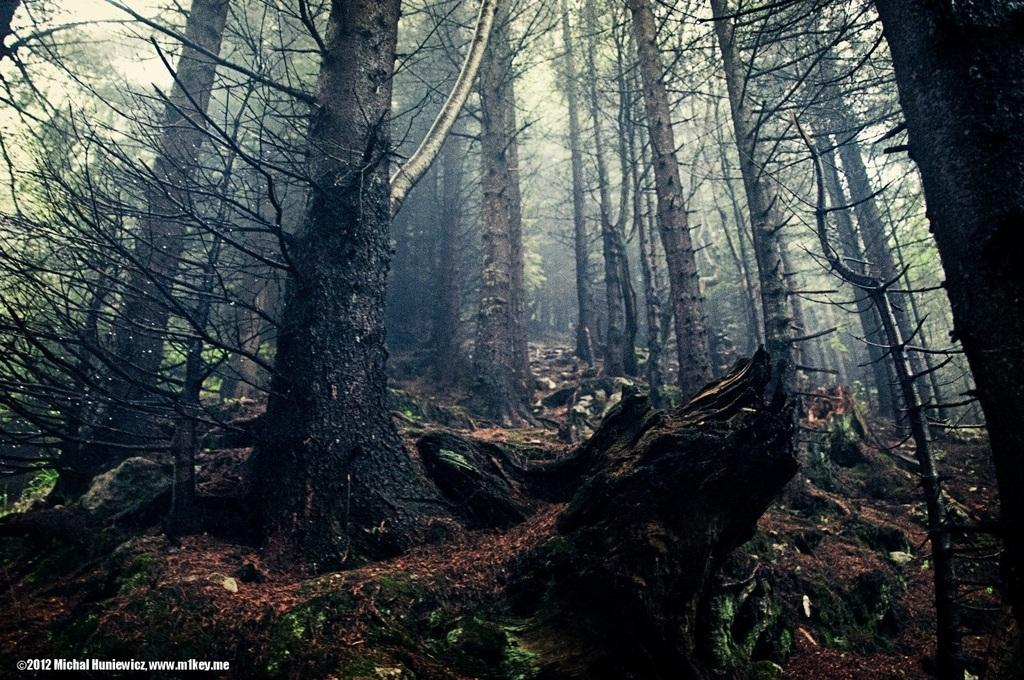What type of vegetation can be seen in the image? There are trees in the image. What is the condition of the sky in the image? The sky is clear in the image. What type of oil can be seen dripping from the trees in the image? There is no oil present in the image; it only features trees and a clear sky. Can you tell me how many birds are perched on the branches of the trees in the image? There are no birds visible in the image; it only features trees and a clear sky. 